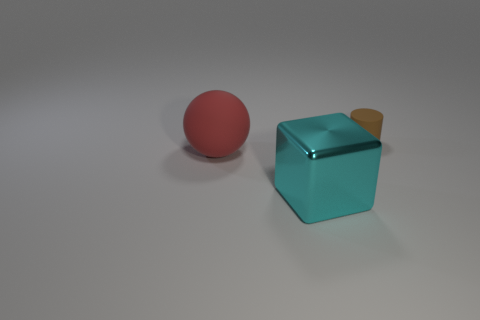Add 1 tiny rubber things. How many objects exist? 4 Subtract all spheres. How many objects are left? 2 Subtract all gray cubes. Subtract all yellow cylinders. How many cubes are left? 1 Subtract all red rubber objects. Subtract all small brown rubber cylinders. How many objects are left? 1 Add 1 large red objects. How many large red objects are left? 2 Add 1 large cyan shiny objects. How many large cyan shiny objects exist? 2 Subtract 0 yellow spheres. How many objects are left? 3 